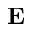<formula> <loc_0><loc_0><loc_500><loc_500>{ E }</formula> 